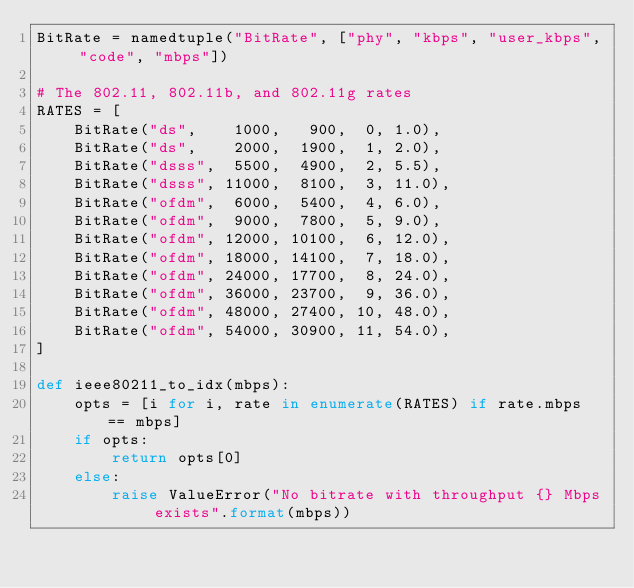<code> <loc_0><loc_0><loc_500><loc_500><_Python_>BitRate = namedtuple("BitRate", ["phy", "kbps", "user_kbps", "code", "mbps"])

# The 802.11, 802.11b, and 802.11g rates
RATES = [
    BitRate("ds",    1000,   900,  0, 1.0),
    BitRate("ds",    2000,  1900,  1, 2.0),
    BitRate("dsss",  5500,  4900,  2, 5.5),
    BitRate("dsss", 11000,  8100,  3, 11.0),
    BitRate("ofdm",  6000,  5400,  4, 6.0),
    BitRate("ofdm",  9000,  7800,  5, 9.0),
    BitRate("ofdm", 12000, 10100,  6, 12.0),
    BitRate("ofdm", 18000, 14100,  7, 18.0),
    BitRate("ofdm", 24000, 17700,  8, 24.0),
    BitRate("ofdm", 36000, 23700,  9, 36.0),
    BitRate("ofdm", 48000, 27400, 10, 48.0),
    BitRate("ofdm", 54000, 30900, 11, 54.0),
]

def ieee80211_to_idx(mbps):
    opts = [i for i, rate in enumerate(RATES) if rate.mbps == mbps]
    if opts:
        return opts[0]
    else:
        raise ValueError("No bitrate with throughput {} Mbps exists".format(mbps))

</code> 